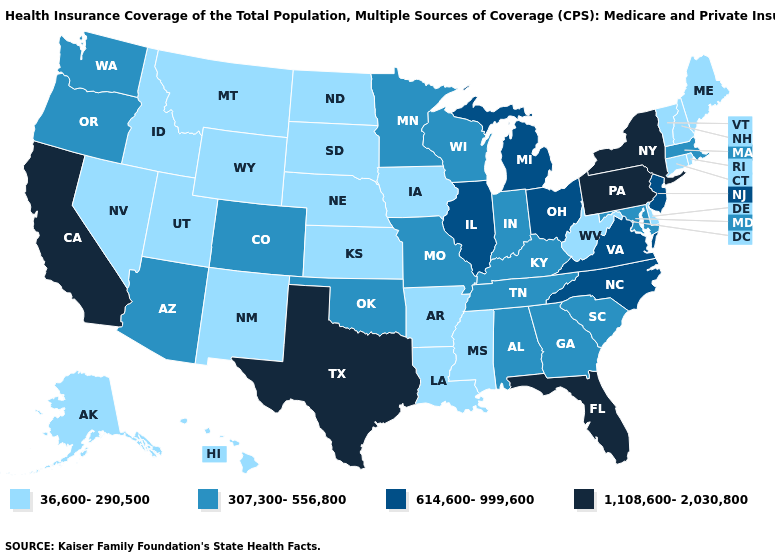Name the states that have a value in the range 36,600-290,500?
Concise answer only. Alaska, Arkansas, Connecticut, Delaware, Hawaii, Idaho, Iowa, Kansas, Louisiana, Maine, Mississippi, Montana, Nebraska, Nevada, New Hampshire, New Mexico, North Dakota, Rhode Island, South Dakota, Utah, Vermont, West Virginia, Wyoming. Name the states that have a value in the range 614,600-999,600?
Be succinct. Illinois, Michigan, New Jersey, North Carolina, Ohio, Virginia. What is the value of Maine?
Write a very short answer. 36,600-290,500. Among the states that border Missouri , does Kansas have the lowest value?
Keep it brief. Yes. Name the states that have a value in the range 36,600-290,500?
Keep it brief. Alaska, Arkansas, Connecticut, Delaware, Hawaii, Idaho, Iowa, Kansas, Louisiana, Maine, Mississippi, Montana, Nebraska, Nevada, New Hampshire, New Mexico, North Dakota, Rhode Island, South Dakota, Utah, Vermont, West Virginia, Wyoming. Which states hav the highest value in the MidWest?
Short answer required. Illinois, Michigan, Ohio. What is the value of New York?
Answer briefly. 1,108,600-2,030,800. What is the highest value in the USA?
Answer briefly. 1,108,600-2,030,800. Name the states that have a value in the range 1,108,600-2,030,800?
Write a very short answer. California, Florida, New York, Pennsylvania, Texas. Name the states that have a value in the range 307,300-556,800?
Give a very brief answer. Alabama, Arizona, Colorado, Georgia, Indiana, Kentucky, Maryland, Massachusetts, Minnesota, Missouri, Oklahoma, Oregon, South Carolina, Tennessee, Washington, Wisconsin. What is the value of Connecticut?
Keep it brief. 36,600-290,500. Does South Carolina have a higher value than Arkansas?
Keep it brief. Yes. Among the states that border South Dakota , does Montana have the highest value?
Give a very brief answer. No. Name the states that have a value in the range 1,108,600-2,030,800?
Answer briefly. California, Florida, New York, Pennsylvania, Texas. Name the states that have a value in the range 614,600-999,600?
Be succinct. Illinois, Michigan, New Jersey, North Carolina, Ohio, Virginia. 